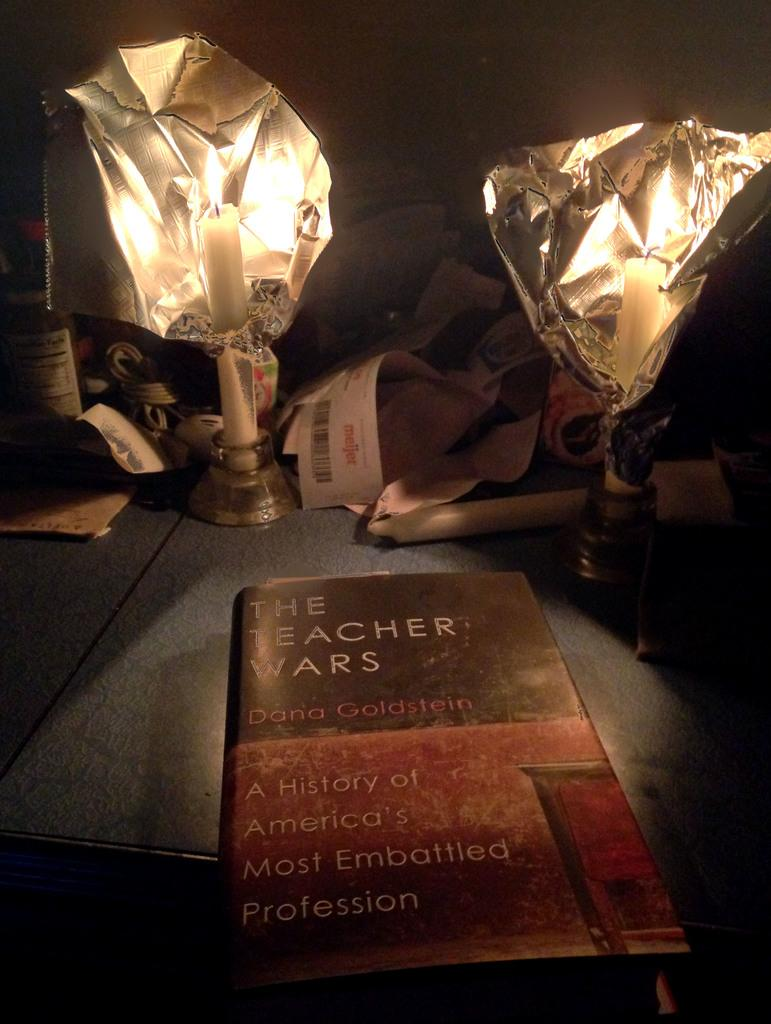<image>
Describe the image concisely. A book called "The Teacher Wars" laid on a table with two candles next to it. 